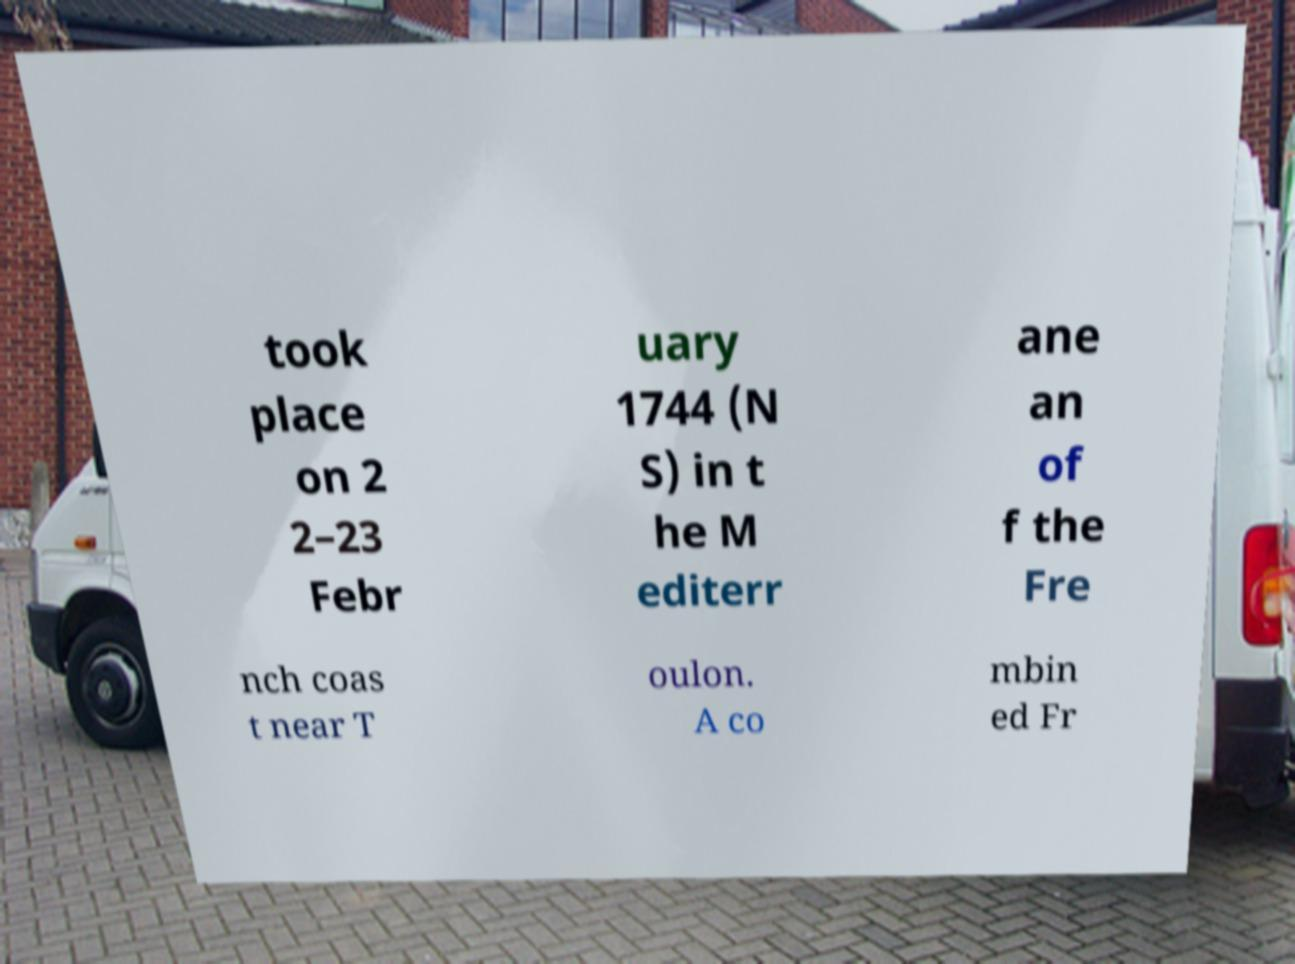Please read and relay the text visible in this image. What does it say? took place on 2 2–23 Febr uary 1744 (N S) in t he M editerr ane an of f the Fre nch coas t near T oulon. A co mbin ed Fr 